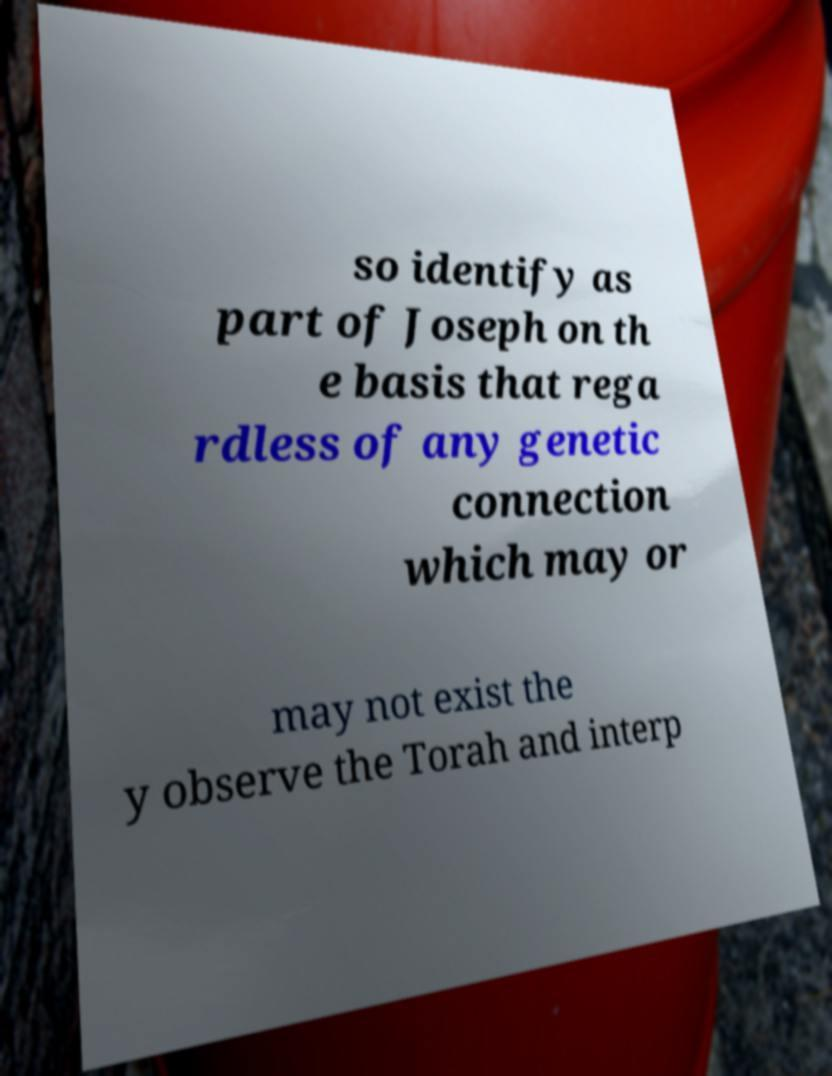Can you read and provide the text displayed in the image?This photo seems to have some interesting text. Can you extract and type it out for me? so identify as part of Joseph on th e basis that rega rdless of any genetic connection which may or may not exist the y observe the Torah and interp 